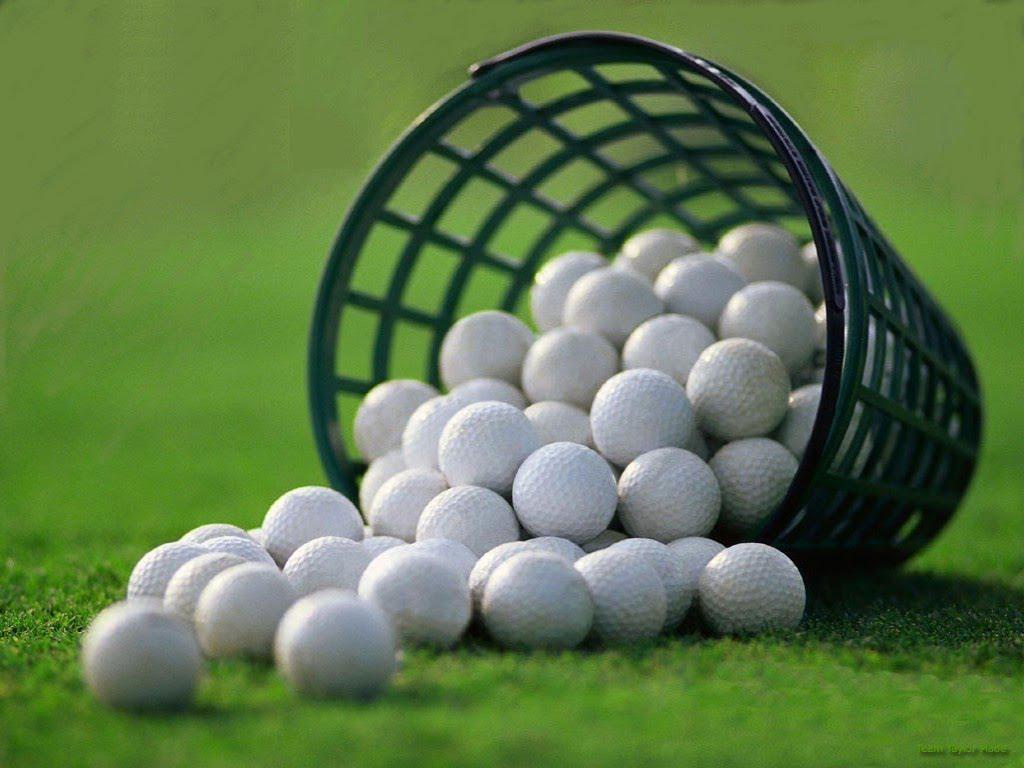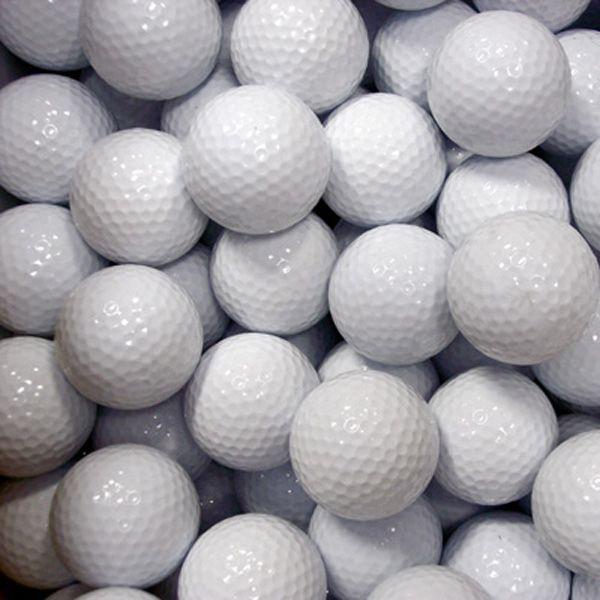The first image is the image on the left, the second image is the image on the right. Assess this claim about the two images: "In one image, all golf balls are on a tee, and in the other image, no golf balls are on a tee.". Correct or not? Answer yes or no. No. 